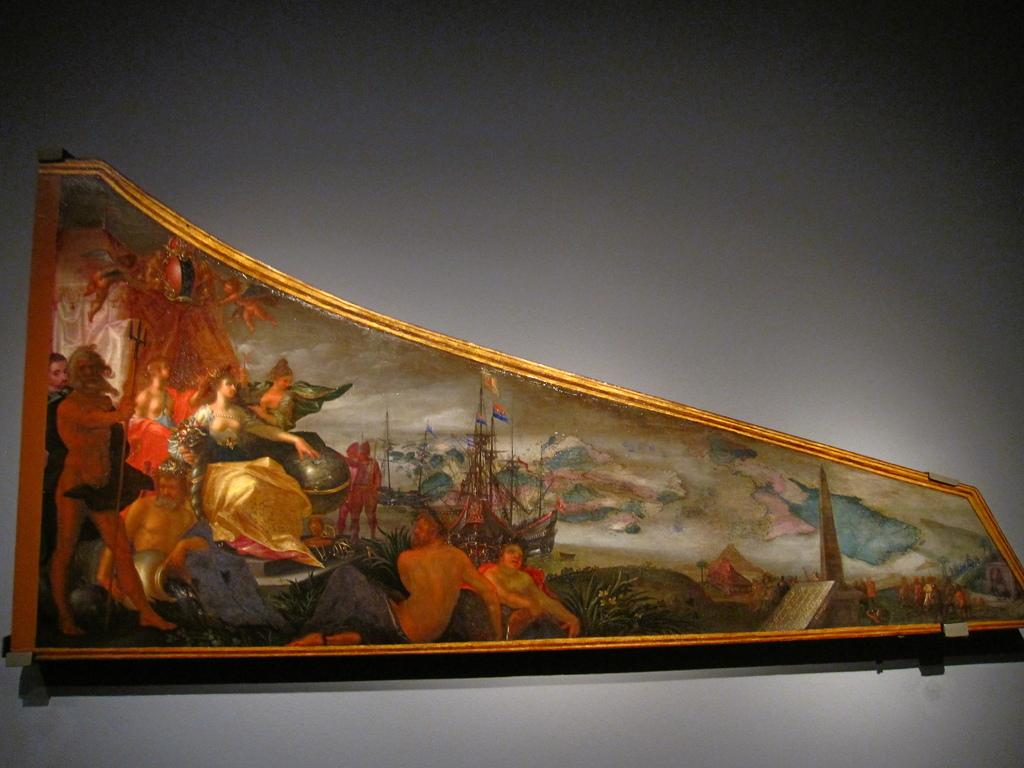What object is in the center of the image? There is a photo frame in the center of the image. Where is the photo frame located? The photo frame is on the wall. Can you describe the position of the photo frame in the image? The photo frame is in the center of the image and on the wall. Is there a volcano erupting in the background of the image? No, there is no volcano or any indication of an eruption in the image. 